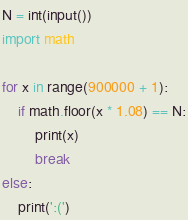<code> <loc_0><loc_0><loc_500><loc_500><_Python_>N = int(input())
import math

for x in range(900000 + 1):
    if math.floor(x * 1.08) == N:
        print(x)
        break
else:
    print(':(')</code> 